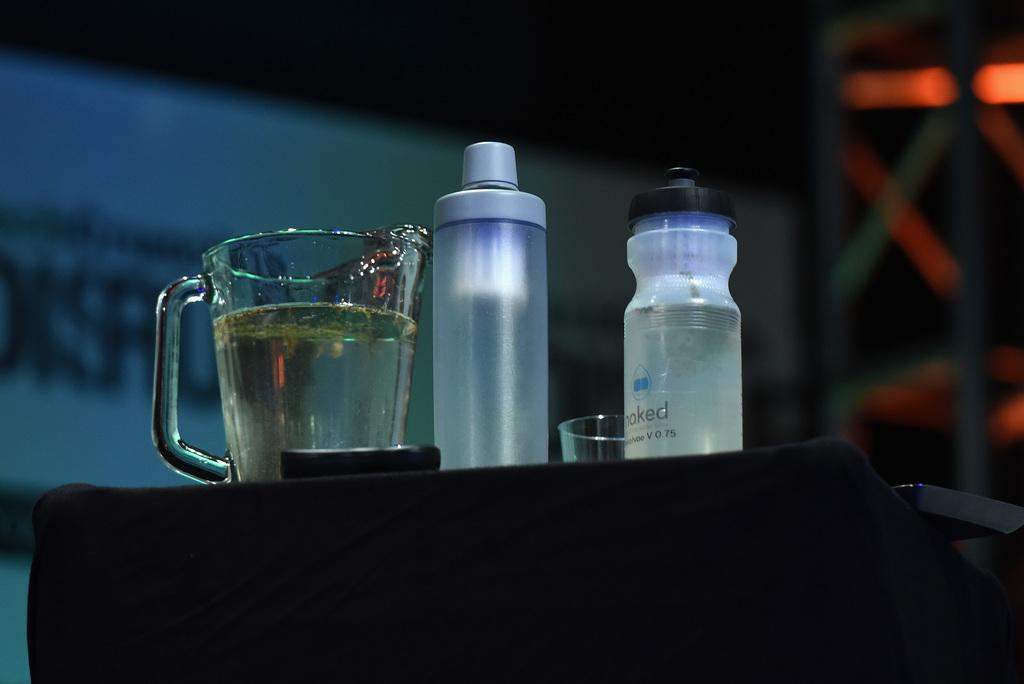How many bottles are visible in the image? There are two bottles in the image. What other drinking vessels can be seen in the image? There is a glass and a mug visible in the image. Where are these objects located in the image? All of these objects are on a table. What type of brush is being used to paint the structure in the image? There is no brush or structure present in the image; it only features two bottles, a glass, and a mug on a table. 